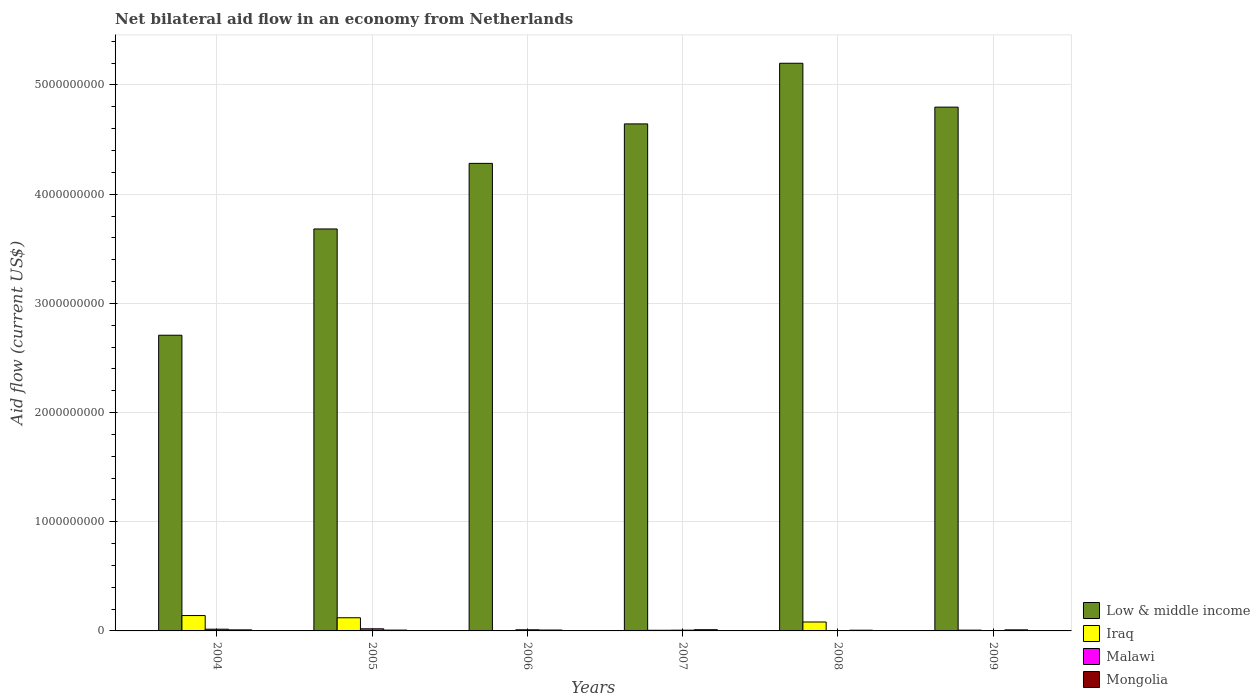How many different coloured bars are there?
Your answer should be compact. 4. How many bars are there on the 4th tick from the right?
Offer a very short reply. 4. What is the label of the 5th group of bars from the left?
Ensure brevity in your answer.  2008. In how many cases, is the number of bars for a given year not equal to the number of legend labels?
Provide a short and direct response. 0. What is the net bilateral aid flow in Malawi in 2009?
Offer a terse response. 8.60e+05. Across all years, what is the maximum net bilateral aid flow in Iraq?
Give a very brief answer. 1.41e+08. Across all years, what is the minimum net bilateral aid flow in Low & middle income?
Your response must be concise. 2.71e+09. In which year was the net bilateral aid flow in Iraq maximum?
Give a very brief answer. 2004. What is the total net bilateral aid flow in Mongolia in the graph?
Your answer should be compact. 5.23e+07. What is the difference between the net bilateral aid flow in Malawi in 2006 and that in 2008?
Offer a very short reply. 1.03e+07. What is the difference between the net bilateral aid flow in Iraq in 2005 and the net bilateral aid flow in Malawi in 2009?
Offer a very short reply. 1.20e+08. What is the average net bilateral aid flow in Malawi per year?
Your response must be concise. 8.90e+06. In the year 2008, what is the difference between the net bilateral aid flow in Malawi and net bilateral aid flow in Low & middle income?
Provide a short and direct response. -5.20e+09. What is the ratio of the net bilateral aid flow in Iraq in 2005 to that in 2006?
Provide a succinct answer. 37.77. Is the net bilateral aid flow in Iraq in 2004 less than that in 2005?
Your answer should be compact. No. Is the difference between the net bilateral aid flow in Malawi in 2005 and 2007 greater than the difference between the net bilateral aid flow in Low & middle income in 2005 and 2007?
Offer a terse response. Yes. What is the difference between the highest and the second highest net bilateral aid flow in Malawi?
Provide a succinct answer. 3.65e+06. What is the difference between the highest and the lowest net bilateral aid flow in Iraq?
Make the answer very short. 1.38e+08. Is the sum of the net bilateral aid flow in Iraq in 2008 and 2009 greater than the maximum net bilateral aid flow in Malawi across all years?
Provide a succinct answer. Yes. Is it the case that in every year, the sum of the net bilateral aid flow in Mongolia and net bilateral aid flow in Low & middle income is greater than the sum of net bilateral aid flow in Iraq and net bilateral aid flow in Malawi?
Provide a short and direct response. No. How many bars are there?
Offer a very short reply. 24. Are all the bars in the graph horizontal?
Your response must be concise. No. How many years are there in the graph?
Your answer should be very brief. 6. What is the difference between two consecutive major ticks on the Y-axis?
Make the answer very short. 1.00e+09. Does the graph contain any zero values?
Provide a short and direct response. No. Where does the legend appear in the graph?
Give a very brief answer. Bottom right. How many legend labels are there?
Give a very brief answer. 4. How are the legend labels stacked?
Provide a succinct answer. Vertical. What is the title of the graph?
Your response must be concise. Net bilateral aid flow in an economy from Netherlands. Does "Georgia" appear as one of the legend labels in the graph?
Offer a terse response. No. What is the label or title of the Y-axis?
Give a very brief answer. Aid flow (current US$). What is the Aid flow (current US$) in Low & middle income in 2004?
Provide a succinct answer. 2.71e+09. What is the Aid flow (current US$) in Iraq in 2004?
Keep it short and to the point. 1.41e+08. What is the Aid flow (current US$) of Malawi in 2004?
Your answer should be compact. 1.58e+07. What is the Aid flow (current US$) in Mongolia in 2004?
Provide a succinct answer. 9.51e+06. What is the Aid flow (current US$) in Low & middle income in 2005?
Ensure brevity in your answer.  3.68e+09. What is the Aid flow (current US$) in Iraq in 2005?
Provide a short and direct response. 1.20e+08. What is the Aid flow (current US$) of Malawi in 2005?
Your answer should be compact. 1.94e+07. What is the Aid flow (current US$) in Mongolia in 2005?
Provide a succinct answer. 7.49e+06. What is the Aid flow (current US$) in Low & middle income in 2006?
Make the answer very short. 4.28e+09. What is the Aid flow (current US$) of Iraq in 2006?
Your answer should be compact. 3.19e+06. What is the Aid flow (current US$) of Malawi in 2006?
Keep it short and to the point. 1.04e+07. What is the Aid flow (current US$) in Mongolia in 2006?
Ensure brevity in your answer.  8.02e+06. What is the Aid flow (current US$) of Low & middle income in 2007?
Offer a terse response. 4.64e+09. What is the Aid flow (current US$) in Iraq in 2007?
Make the answer very short. 5.94e+06. What is the Aid flow (current US$) in Malawi in 2007?
Your answer should be compact. 6.80e+06. What is the Aid flow (current US$) in Mongolia in 2007?
Offer a terse response. 1.11e+07. What is the Aid flow (current US$) in Low & middle income in 2008?
Keep it short and to the point. 5.20e+09. What is the Aid flow (current US$) in Iraq in 2008?
Your response must be concise. 8.18e+07. What is the Aid flow (current US$) of Malawi in 2008?
Offer a terse response. 1.30e+05. What is the Aid flow (current US$) of Mongolia in 2008?
Ensure brevity in your answer.  6.55e+06. What is the Aid flow (current US$) of Low & middle income in 2009?
Your answer should be compact. 4.80e+09. What is the Aid flow (current US$) in Iraq in 2009?
Provide a succinct answer. 7.27e+06. What is the Aid flow (current US$) of Malawi in 2009?
Give a very brief answer. 8.60e+05. What is the Aid flow (current US$) in Mongolia in 2009?
Ensure brevity in your answer.  9.62e+06. Across all years, what is the maximum Aid flow (current US$) of Low & middle income?
Give a very brief answer. 5.20e+09. Across all years, what is the maximum Aid flow (current US$) of Iraq?
Ensure brevity in your answer.  1.41e+08. Across all years, what is the maximum Aid flow (current US$) in Malawi?
Offer a terse response. 1.94e+07. Across all years, what is the maximum Aid flow (current US$) of Mongolia?
Your answer should be compact. 1.11e+07. Across all years, what is the minimum Aid flow (current US$) in Low & middle income?
Ensure brevity in your answer.  2.71e+09. Across all years, what is the minimum Aid flow (current US$) in Iraq?
Provide a succinct answer. 3.19e+06. Across all years, what is the minimum Aid flow (current US$) in Malawi?
Offer a terse response. 1.30e+05. Across all years, what is the minimum Aid flow (current US$) in Mongolia?
Provide a succinct answer. 6.55e+06. What is the total Aid flow (current US$) of Low & middle income in the graph?
Give a very brief answer. 2.53e+1. What is the total Aid flow (current US$) of Iraq in the graph?
Provide a short and direct response. 3.60e+08. What is the total Aid flow (current US$) in Malawi in the graph?
Give a very brief answer. 5.34e+07. What is the total Aid flow (current US$) of Mongolia in the graph?
Provide a short and direct response. 5.23e+07. What is the difference between the Aid flow (current US$) of Low & middle income in 2004 and that in 2005?
Provide a succinct answer. -9.73e+08. What is the difference between the Aid flow (current US$) of Iraq in 2004 and that in 2005?
Offer a very short reply. 2.03e+07. What is the difference between the Aid flow (current US$) in Malawi in 2004 and that in 2005?
Your response must be concise. -3.65e+06. What is the difference between the Aid flow (current US$) in Mongolia in 2004 and that in 2005?
Ensure brevity in your answer.  2.02e+06. What is the difference between the Aid flow (current US$) of Low & middle income in 2004 and that in 2006?
Provide a succinct answer. -1.57e+09. What is the difference between the Aid flow (current US$) of Iraq in 2004 and that in 2006?
Ensure brevity in your answer.  1.38e+08. What is the difference between the Aid flow (current US$) of Malawi in 2004 and that in 2006?
Your response must be concise. 5.32e+06. What is the difference between the Aid flow (current US$) of Mongolia in 2004 and that in 2006?
Your answer should be compact. 1.49e+06. What is the difference between the Aid flow (current US$) of Low & middle income in 2004 and that in 2007?
Make the answer very short. -1.94e+09. What is the difference between the Aid flow (current US$) in Iraq in 2004 and that in 2007?
Make the answer very short. 1.35e+08. What is the difference between the Aid flow (current US$) of Malawi in 2004 and that in 2007?
Provide a short and direct response. 8.96e+06. What is the difference between the Aid flow (current US$) of Mongolia in 2004 and that in 2007?
Your answer should be very brief. -1.63e+06. What is the difference between the Aid flow (current US$) of Low & middle income in 2004 and that in 2008?
Make the answer very short. -2.49e+09. What is the difference between the Aid flow (current US$) of Iraq in 2004 and that in 2008?
Provide a short and direct response. 5.90e+07. What is the difference between the Aid flow (current US$) of Malawi in 2004 and that in 2008?
Provide a succinct answer. 1.56e+07. What is the difference between the Aid flow (current US$) in Mongolia in 2004 and that in 2008?
Your answer should be compact. 2.96e+06. What is the difference between the Aid flow (current US$) of Low & middle income in 2004 and that in 2009?
Offer a very short reply. -2.09e+09. What is the difference between the Aid flow (current US$) of Iraq in 2004 and that in 2009?
Offer a very short reply. 1.34e+08. What is the difference between the Aid flow (current US$) in Malawi in 2004 and that in 2009?
Keep it short and to the point. 1.49e+07. What is the difference between the Aid flow (current US$) of Low & middle income in 2005 and that in 2006?
Make the answer very short. -6.01e+08. What is the difference between the Aid flow (current US$) in Iraq in 2005 and that in 2006?
Your answer should be compact. 1.17e+08. What is the difference between the Aid flow (current US$) of Malawi in 2005 and that in 2006?
Offer a terse response. 8.97e+06. What is the difference between the Aid flow (current US$) in Mongolia in 2005 and that in 2006?
Your answer should be very brief. -5.30e+05. What is the difference between the Aid flow (current US$) in Low & middle income in 2005 and that in 2007?
Your answer should be compact. -9.62e+08. What is the difference between the Aid flow (current US$) in Iraq in 2005 and that in 2007?
Your response must be concise. 1.15e+08. What is the difference between the Aid flow (current US$) in Malawi in 2005 and that in 2007?
Your answer should be compact. 1.26e+07. What is the difference between the Aid flow (current US$) in Mongolia in 2005 and that in 2007?
Provide a short and direct response. -3.65e+06. What is the difference between the Aid flow (current US$) of Low & middle income in 2005 and that in 2008?
Ensure brevity in your answer.  -1.52e+09. What is the difference between the Aid flow (current US$) of Iraq in 2005 and that in 2008?
Your answer should be compact. 3.87e+07. What is the difference between the Aid flow (current US$) in Malawi in 2005 and that in 2008?
Provide a succinct answer. 1.93e+07. What is the difference between the Aid flow (current US$) of Mongolia in 2005 and that in 2008?
Give a very brief answer. 9.40e+05. What is the difference between the Aid flow (current US$) of Low & middle income in 2005 and that in 2009?
Provide a short and direct response. -1.12e+09. What is the difference between the Aid flow (current US$) of Iraq in 2005 and that in 2009?
Your response must be concise. 1.13e+08. What is the difference between the Aid flow (current US$) in Malawi in 2005 and that in 2009?
Keep it short and to the point. 1.86e+07. What is the difference between the Aid flow (current US$) in Mongolia in 2005 and that in 2009?
Your response must be concise. -2.13e+06. What is the difference between the Aid flow (current US$) of Low & middle income in 2006 and that in 2007?
Keep it short and to the point. -3.62e+08. What is the difference between the Aid flow (current US$) in Iraq in 2006 and that in 2007?
Your answer should be compact. -2.75e+06. What is the difference between the Aid flow (current US$) in Malawi in 2006 and that in 2007?
Your answer should be very brief. 3.64e+06. What is the difference between the Aid flow (current US$) in Mongolia in 2006 and that in 2007?
Keep it short and to the point. -3.12e+06. What is the difference between the Aid flow (current US$) of Low & middle income in 2006 and that in 2008?
Keep it short and to the point. -9.17e+08. What is the difference between the Aid flow (current US$) of Iraq in 2006 and that in 2008?
Provide a short and direct response. -7.86e+07. What is the difference between the Aid flow (current US$) in Malawi in 2006 and that in 2008?
Keep it short and to the point. 1.03e+07. What is the difference between the Aid flow (current US$) of Mongolia in 2006 and that in 2008?
Keep it short and to the point. 1.47e+06. What is the difference between the Aid flow (current US$) in Low & middle income in 2006 and that in 2009?
Make the answer very short. -5.15e+08. What is the difference between the Aid flow (current US$) in Iraq in 2006 and that in 2009?
Give a very brief answer. -4.08e+06. What is the difference between the Aid flow (current US$) of Malawi in 2006 and that in 2009?
Provide a short and direct response. 9.58e+06. What is the difference between the Aid flow (current US$) of Mongolia in 2006 and that in 2009?
Your answer should be compact. -1.60e+06. What is the difference between the Aid flow (current US$) in Low & middle income in 2007 and that in 2008?
Your answer should be very brief. -5.55e+08. What is the difference between the Aid flow (current US$) in Iraq in 2007 and that in 2008?
Offer a terse response. -7.59e+07. What is the difference between the Aid flow (current US$) in Malawi in 2007 and that in 2008?
Keep it short and to the point. 6.67e+06. What is the difference between the Aid flow (current US$) of Mongolia in 2007 and that in 2008?
Your answer should be very brief. 4.59e+06. What is the difference between the Aid flow (current US$) in Low & middle income in 2007 and that in 2009?
Offer a terse response. -1.54e+08. What is the difference between the Aid flow (current US$) of Iraq in 2007 and that in 2009?
Ensure brevity in your answer.  -1.33e+06. What is the difference between the Aid flow (current US$) of Malawi in 2007 and that in 2009?
Provide a short and direct response. 5.94e+06. What is the difference between the Aid flow (current US$) of Mongolia in 2007 and that in 2009?
Give a very brief answer. 1.52e+06. What is the difference between the Aid flow (current US$) of Low & middle income in 2008 and that in 2009?
Give a very brief answer. 4.02e+08. What is the difference between the Aid flow (current US$) in Iraq in 2008 and that in 2009?
Ensure brevity in your answer.  7.45e+07. What is the difference between the Aid flow (current US$) in Malawi in 2008 and that in 2009?
Provide a short and direct response. -7.30e+05. What is the difference between the Aid flow (current US$) in Mongolia in 2008 and that in 2009?
Your response must be concise. -3.07e+06. What is the difference between the Aid flow (current US$) of Low & middle income in 2004 and the Aid flow (current US$) of Iraq in 2005?
Ensure brevity in your answer.  2.59e+09. What is the difference between the Aid flow (current US$) in Low & middle income in 2004 and the Aid flow (current US$) in Malawi in 2005?
Make the answer very short. 2.69e+09. What is the difference between the Aid flow (current US$) of Low & middle income in 2004 and the Aid flow (current US$) of Mongolia in 2005?
Keep it short and to the point. 2.70e+09. What is the difference between the Aid flow (current US$) of Iraq in 2004 and the Aid flow (current US$) of Malawi in 2005?
Give a very brief answer. 1.21e+08. What is the difference between the Aid flow (current US$) in Iraq in 2004 and the Aid flow (current US$) in Mongolia in 2005?
Provide a succinct answer. 1.33e+08. What is the difference between the Aid flow (current US$) of Malawi in 2004 and the Aid flow (current US$) of Mongolia in 2005?
Ensure brevity in your answer.  8.27e+06. What is the difference between the Aid flow (current US$) of Low & middle income in 2004 and the Aid flow (current US$) of Iraq in 2006?
Make the answer very short. 2.71e+09. What is the difference between the Aid flow (current US$) in Low & middle income in 2004 and the Aid flow (current US$) in Malawi in 2006?
Offer a very short reply. 2.70e+09. What is the difference between the Aid flow (current US$) in Low & middle income in 2004 and the Aid flow (current US$) in Mongolia in 2006?
Keep it short and to the point. 2.70e+09. What is the difference between the Aid flow (current US$) in Iraq in 2004 and the Aid flow (current US$) in Malawi in 2006?
Your answer should be very brief. 1.30e+08. What is the difference between the Aid flow (current US$) in Iraq in 2004 and the Aid flow (current US$) in Mongolia in 2006?
Provide a succinct answer. 1.33e+08. What is the difference between the Aid flow (current US$) of Malawi in 2004 and the Aid flow (current US$) of Mongolia in 2006?
Make the answer very short. 7.74e+06. What is the difference between the Aid flow (current US$) of Low & middle income in 2004 and the Aid flow (current US$) of Iraq in 2007?
Keep it short and to the point. 2.70e+09. What is the difference between the Aid flow (current US$) of Low & middle income in 2004 and the Aid flow (current US$) of Malawi in 2007?
Offer a terse response. 2.70e+09. What is the difference between the Aid flow (current US$) in Low & middle income in 2004 and the Aid flow (current US$) in Mongolia in 2007?
Offer a terse response. 2.70e+09. What is the difference between the Aid flow (current US$) in Iraq in 2004 and the Aid flow (current US$) in Malawi in 2007?
Ensure brevity in your answer.  1.34e+08. What is the difference between the Aid flow (current US$) of Iraq in 2004 and the Aid flow (current US$) of Mongolia in 2007?
Your response must be concise. 1.30e+08. What is the difference between the Aid flow (current US$) of Malawi in 2004 and the Aid flow (current US$) of Mongolia in 2007?
Your answer should be very brief. 4.62e+06. What is the difference between the Aid flow (current US$) of Low & middle income in 2004 and the Aid flow (current US$) of Iraq in 2008?
Your answer should be compact. 2.63e+09. What is the difference between the Aid flow (current US$) of Low & middle income in 2004 and the Aid flow (current US$) of Malawi in 2008?
Your answer should be very brief. 2.71e+09. What is the difference between the Aid flow (current US$) of Low & middle income in 2004 and the Aid flow (current US$) of Mongolia in 2008?
Provide a short and direct response. 2.70e+09. What is the difference between the Aid flow (current US$) in Iraq in 2004 and the Aid flow (current US$) in Malawi in 2008?
Give a very brief answer. 1.41e+08. What is the difference between the Aid flow (current US$) of Iraq in 2004 and the Aid flow (current US$) of Mongolia in 2008?
Provide a succinct answer. 1.34e+08. What is the difference between the Aid flow (current US$) of Malawi in 2004 and the Aid flow (current US$) of Mongolia in 2008?
Offer a terse response. 9.21e+06. What is the difference between the Aid flow (current US$) in Low & middle income in 2004 and the Aid flow (current US$) in Iraq in 2009?
Offer a very short reply. 2.70e+09. What is the difference between the Aid flow (current US$) in Low & middle income in 2004 and the Aid flow (current US$) in Malawi in 2009?
Keep it short and to the point. 2.71e+09. What is the difference between the Aid flow (current US$) in Low & middle income in 2004 and the Aid flow (current US$) in Mongolia in 2009?
Make the answer very short. 2.70e+09. What is the difference between the Aid flow (current US$) in Iraq in 2004 and the Aid flow (current US$) in Malawi in 2009?
Make the answer very short. 1.40e+08. What is the difference between the Aid flow (current US$) in Iraq in 2004 and the Aid flow (current US$) in Mongolia in 2009?
Your response must be concise. 1.31e+08. What is the difference between the Aid flow (current US$) of Malawi in 2004 and the Aid flow (current US$) of Mongolia in 2009?
Provide a short and direct response. 6.14e+06. What is the difference between the Aid flow (current US$) of Low & middle income in 2005 and the Aid flow (current US$) of Iraq in 2006?
Offer a very short reply. 3.68e+09. What is the difference between the Aid flow (current US$) of Low & middle income in 2005 and the Aid flow (current US$) of Malawi in 2006?
Make the answer very short. 3.67e+09. What is the difference between the Aid flow (current US$) of Low & middle income in 2005 and the Aid flow (current US$) of Mongolia in 2006?
Your response must be concise. 3.67e+09. What is the difference between the Aid flow (current US$) in Iraq in 2005 and the Aid flow (current US$) in Malawi in 2006?
Give a very brief answer. 1.10e+08. What is the difference between the Aid flow (current US$) in Iraq in 2005 and the Aid flow (current US$) in Mongolia in 2006?
Offer a very short reply. 1.12e+08. What is the difference between the Aid flow (current US$) in Malawi in 2005 and the Aid flow (current US$) in Mongolia in 2006?
Keep it short and to the point. 1.14e+07. What is the difference between the Aid flow (current US$) in Low & middle income in 2005 and the Aid flow (current US$) in Iraq in 2007?
Ensure brevity in your answer.  3.68e+09. What is the difference between the Aid flow (current US$) of Low & middle income in 2005 and the Aid flow (current US$) of Malawi in 2007?
Offer a very short reply. 3.67e+09. What is the difference between the Aid flow (current US$) in Low & middle income in 2005 and the Aid flow (current US$) in Mongolia in 2007?
Offer a very short reply. 3.67e+09. What is the difference between the Aid flow (current US$) in Iraq in 2005 and the Aid flow (current US$) in Malawi in 2007?
Your response must be concise. 1.14e+08. What is the difference between the Aid flow (current US$) of Iraq in 2005 and the Aid flow (current US$) of Mongolia in 2007?
Your answer should be very brief. 1.09e+08. What is the difference between the Aid flow (current US$) of Malawi in 2005 and the Aid flow (current US$) of Mongolia in 2007?
Your response must be concise. 8.27e+06. What is the difference between the Aid flow (current US$) of Low & middle income in 2005 and the Aid flow (current US$) of Iraq in 2008?
Make the answer very short. 3.60e+09. What is the difference between the Aid flow (current US$) of Low & middle income in 2005 and the Aid flow (current US$) of Malawi in 2008?
Your response must be concise. 3.68e+09. What is the difference between the Aid flow (current US$) in Low & middle income in 2005 and the Aid flow (current US$) in Mongolia in 2008?
Provide a succinct answer. 3.67e+09. What is the difference between the Aid flow (current US$) in Iraq in 2005 and the Aid flow (current US$) in Malawi in 2008?
Provide a short and direct response. 1.20e+08. What is the difference between the Aid flow (current US$) of Iraq in 2005 and the Aid flow (current US$) of Mongolia in 2008?
Make the answer very short. 1.14e+08. What is the difference between the Aid flow (current US$) of Malawi in 2005 and the Aid flow (current US$) of Mongolia in 2008?
Your answer should be compact. 1.29e+07. What is the difference between the Aid flow (current US$) of Low & middle income in 2005 and the Aid flow (current US$) of Iraq in 2009?
Your answer should be compact. 3.67e+09. What is the difference between the Aid flow (current US$) in Low & middle income in 2005 and the Aid flow (current US$) in Malawi in 2009?
Ensure brevity in your answer.  3.68e+09. What is the difference between the Aid flow (current US$) in Low & middle income in 2005 and the Aid flow (current US$) in Mongolia in 2009?
Provide a short and direct response. 3.67e+09. What is the difference between the Aid flow (current US$) of Iraq in 2005 and the Aid flow (current US$) of Malawi in 2009?
Provide a short and direct response. 1.20e+08. What is the difference between the Aid flow (current US$) of Iraq in 2005 and the Aid flow (current US$) of Mongolia in 2009?
Make the answer very short. 1.11e+08. What is the difference between the Aid flow (current US$) of Malawi in 2005 and the Aid flow (current US$) of Mongolia in 2009?
Make the answer very short. 9.79e+06. What is the difference between the Aid flow (current US$) in Low & middle income in 2006 and the Aid flow (current US$) in Iraq in 2007?
Keep it short and to the point. 4.28e+09. What is the difference between the Aid flow (current US$) in Low & middle income in 2006 and the Aid flow (current US$) in Malawi in 2007?
Give a very brief answer. 4.28e+09. What is the difference between the Aid flow (current US$) of Low & middle income in 2006 and the Aid flow (current US$) of Mongolia in 2007?
Keep it short and to the point. 4.27e+09. What is the difference between the Aid flow (current US$) in Iraq in 2006 and the Aid flow (current US$) in Malawi in 2007?
Your answer should be very brief. -3.61e+06. What is the difference between the Aid flow (current US$) in Iraq in 2006 and the Aid flow (current US$) in Mongolia in 2007?
Provide a succinct answer. -7.95e+06. What is the difference between the Aid flow (current US$) of Malawi in 2006 and the Aid flow (current US$) of Mongolia in 2007?
Offer a terse response. -7.00e+05. What is the difference between the Aid flow (current US$) in Low & middle income in 2006 and the Aid flow (current US$) in Iraq in 2008?
Your response must be concise. 4.20e+09. What is the difference between the Aid flow (current US$) of Low & middle income in 2006 and the Aid flow (current US$) of Malawi in 2008?
Provide a succinct answer. 4.28e+09. What is the difference between the Aid flow (current US$) of Low & middle income in 2006 and the Aid flow (current US$) of Mongolia in 2008?
Give a very brief answer. 4.28e+09. What is the difference between the Aid flow (current US$) in Iraq in 2006 and the Aid flow (current US$) in Malawi in 2008?
Offer a very short reply. 3.06e+06. What is the difference between the Aid flow (current US$) of Iraq in 2006 and the Aid flow (current US$) of Mongolia in 2008?
Your answer should be very brief. -3.36e+06. What is the difference between the Aid flow (current US$) of Malawi in 2006 and the Aid flow (current US$) of Mongolia in 2008?
Provide a short and direct response. 3.89e+06. What is the difference between the Aid flow (current US$) of Low & middle income in 2006 and the Aid flow (current US$) of Iraq in 2009?
Your answer should be compact. 4.27e+09. What is the difference between the Aid flow (current US$) of Low & middle income in 2006 and the Aid flow (current US$) of Malawi in 2009?
Ensure brevity in your answer.  4.28e+09. What is the difference between the Aid flow (current US$) of Low & middle income in 2006 and the Aid flow (current US$) of Mongolia in 2009?
Your answer should be compact. 4.27e+09. What is the difference between the Aid flow (current US$) in Iraq in 2006 and the Aid flow (current US$) in Malawi in 2009?
Keep it short and to the point. 2.33e+06. What is the difference between the Aid flow (current US$) in Iraq in 2006 and the Aid flow (current US$) in Mongolia in 2009?
Keep it short and to the point. -6.43e+06. What is the difference between the Aid flow (current US$) of Malawi in 2006 and the Aid flow (current US$) of Mongolia in 2009?
Offer a very short reply. 8.20e+05. What is the difference between the Aid flow (current US$) of Low & middle income in 2007 and the Aid flow (current US$) of Iraq in 2008?
Your answer should be very brief. 4.56e+09. What is the difference between the Aid flow (current US$) of Low & middle income in 2007 and the Aid flow (current US$) of Malawi in 2008?
Offer a terse response. 4.64e+09. What is the difference between the Aid flow (current US$) in Low & middle income in 2007 and the Aid flow (current US$) in Mongolia in 2008?
Offer a terse response. 4.64e+09. What is the difference between the Aid flow (current US$) in Iraq in 2007 and the Aid flow (current US$) in Malawi in 2008?
Your response must be concise. 5.81e+06. What is the difference between the Aid flow (current US$) in Iraq in 2007 and the Aid flow (current US$) in Mongolia in 2008?
Provide a short and direct response. -6.10e+05. What is the difference between the Aid flow (current US$) in Malawi in 2007 and the Aid flow (current US$) in Mongolia in 2008?
Provide a succinct answer. 2.50e+05. What is the difference between the Aid flow (current US$) of Low & middle income in 2007 and the Aid flow (current US$) of Iraq in 2009?
Offer a terse response. 4.64e+09. What is the difference between the Aid flow (current US$) in Low & middle income in 2007 and the Aid flow (current US$) in Malawi in 2009?
Your answer should be very brief. 4.64e+09. What is the difference between the Aid flow (current US$) in Low & middle income in 2007 and the Aid flow (current US$) in Mongolia in 2009?
Make the answer very short. 4.63e+09. What is the difference between the Aid flow (current US$) in Iraq in 2007 and the Aid flow (current US$) in Malawi in 2009?
Offer a terse response. 5.08e+06. What is the difference between the Aid flow (current US$) in Iraq in 2007 and the Aid flow (current US$) in Mongolia in 2009?
Offer a very short reply. -3.68e+06. What is the difference between the Aid flow (current US$) in Malawi in 2007 and the Aid flow (current US$) in Mongolia in 2009?
Make the answer very short. -2.82e+06. What is the difference between the Aid flow (current US$) of Low & middle income in 2008 and the Aid flow (current US$) of Iraq in 2009?
Make the answer very short. 5.19e+09. What is the difference between the Aid flow (current US$) of Low & middle income in 2008 and the Aid flow (current US$) of Malawi in 2009?
Keep it short and to the point. 5.20e+09. What is the difference between the Aid flow (current US$) in Low & middle income in 2008 and the Aid flow (current US$) in Mongolia in 2009?
Your answer should be very brief. 5.19e+09. What is the difference between the Aid flow (current US$) in Iraq in 2008 and the Aid flow (current US$) in Malawi in 2009?
Your answer should be compact. 8.10e+07. What is the difference between the Aid flow (current US$) of Iraq in 2008 and the Aid flow (current US$) of Mongolia in 2009?
Your answer should be compact. 7.22e+07. What is the difference between the Aid flow (current US$) of Malawi in 2008 and the Aid flow (current US$) of Mongolia in 2009?
Offer a terse response. -9.49e+06. What is the average Aid flow (current US$) of Low & middle income per year?
Make the answer very short. 4.22e+09. What is the average Aid flow (current US$) in Iraq per year?
Provide a succinct answer. 5.99e+07. What is the average Aid flow (current US$) of Malawi per year?
Keep it short and to the point. 8.90e+06. What is the average Aid flow (current US$) of Mongolia per year?
Ensure brevity in your answer.  8.72e+06. In the year 2004, what is the difference between the Aid flow (current US$) of Low & middle income and Aid flow (current US$) of Iraq?
Your answer should be very brief. 2.57e+09. In the year 2004, what is the difference between the Aid flow (current US$) of Low & middle income and Aid flow (current US$) of Malawi?
Offer a terse response. 2.69e+09. In the year 2004, what is the difference between the Aid flow (current US$) of Low & middle income and Aid flow (current US$) of Mongolia?
Provide a succinct answer. 2.70e+09. In the year 2004, what is the difference between the Aid flow (current US$) of Iraq and Aid flow (current US$) of Malawi?
Your answer should be very brief. 1.25e+08. In the year 2004, what is the difference between the Aid flow (current US$) of Iraq and Aid flow (current US$) of Mongolia?
Make the answer very short. 1.31e+08. In the year 2004, what is the difference between the Aid flow (current US$) in Malawi and Aid flow (current US$) in Mongolia?
Offer a very short reply. 6.25e+06. In the year 2005, what is the difference between the Aid flow (current US$) in Low & middle income and Aid flow (current US$) in Iraq?
Ensure brevity in your answer.  3.56e+09. In the year 2005, what is the difference between the Aid flow (current US$) in Low & middle income and Aid flow (current US$) in Malawi?
Your answer should be very brief. 3.66e+09. In the year 2005, what is the difference between the Aid flow (current US$) in Low & middle income and Aid flow (current US$) in Mongolia?
Provide a succinct answer. 3.67e+09. In the year 2005, what is the difference between the Aid flow (current US$) of Iraq and Aid flow (current US$) of Malawi?
Offer a terse response. 1.01e+08. In the year 2005, what is the difference between the Aid flow (current US$) of Iraq and Aid flow (current US$) of Mongolia?
Offer a very short reply. 1.13e+08. In the year 2005, what is the difference between the Aid flow (current US$) of Malawi and Aid flow (current US$) of Mongolia?
Give a very brief answer. 1.19e+07. In the year 2006, what is the difference between the Aid flow (current US$) of Low & middle income and Aid flow (current US$) of Iraq?
Give a very brief answer. 4.28e+09. In the year 2006, what is the difference between the Aid flow (current US$) in Low & middle income and Aid flow (current US$) in Malawi?
Ensure brevity in your answer.  4.27e+09. In the year 2006, what is the difference between the Aid flow (current US$) of Low & middle income and Aid flow (current US$) of Mongolia?
Make the answer very short. 4.27e+09. In the year 2006, what is the difference between the Aid flow (current US$) of Iraq and Aid flow (current US$) of Malawi?
Provide a short and direct response. -7.25e+06. In the year 2006, what is the difference between the Aid flow (current US$) of Iraq and Aid flow (current US$) of Mongolia?
Your answer should be compact. -4.83e+06. In the year 2006, what is the difference between the Aid flow (current US$) of Malawi and Aid flow (current US$) of Mongolia?
Your answer should be compact. 2.42e+06. In the year 2007, what is the difference between the Aid flow (current US$) of Low & middle income and Aid flow (current US$) of Iraq?
Your response must be concise. 4.64e+09. In the year 2007, what is the difference between the Aid flow (current US$) in Low & middle income and Aid flow (current US$) in Malawi?
Your answer should be very brief. 4.64e+09. In the year 2007, what is the difference between the Aid flow (current US$) in Low & middle income and Aid flow (current US$) in Mongolia?
Keep it short and to the point. 4.63e+09. In the year 2007, what is the difference between the Aid flow (current US$) in Iraq and Aid flow (current US$) in Malawi?
Offer a very short reply. -8.60e+05. In the year 2007, what is the difference between the Aid flow (current US$) of Iraq and Aid flow (current US$) of Mongolia?
Offer a very short reply. -5.20e+06. In the year 2007, what is the difference between the Aid flow (current US$) of Malawi and Aid flow (current US$) of Mongolia?
Offer a terse response. -4.34e+06. In the year 2008, what is the difference between the Aid flow (current US$) in Low & middle income and Aid flow (current US$) in Iraq?
Ensure brevity in your answer.  5.12e+09. In the year 2008, what is the difference between the Aid flow (current US$) of Low & middle income and Aid flow (current US$) of Malawi?
Your answer should be very brief. 5.20e+09. In the year 2008, what is the difference between the Aid flow (current US$) of Low & middle income and Aid flow (current US$) of Mongolia?
Your answer should be compact. 5.19e+09. In the year 2008, what is the difference between the Aid flow (current US$) of Iraq and Aid flow (current US$) of Malawi?
Ensure brevity in your answer.  8.17e+07. In the year 2008, what is the difference between the Aid flow (current US$) in Iraq and Aid flow (current US$) in Mongolia?
Your answer should be compact. 7.53e+07. In the year 2008, what is the difference between the Aid flow (current US$) of Malawi and Aid flow (current US$) of Mongolia?
Make the answer very short. -6.42e+06. In the year 2009, what is the difference between the Aid flow (current US$) in Low & middle income and Aid flow (current US$) in Iraq?
Offer a terse response. 4.79e+09. In the year 2009, what is the difference between the Aid flow (current US$) of Low & middle income and Aid flow (current US$) of Malawi?
Your answer should be very brief. 4.80e+09. In the year 2009, what is the difference between the Aid flow (current US$) of Low & middle income and Aid flow (current US$) of Mongolia?
Make the answer very short. 4.79e+09. In the year 2009, what is the difference between the Aid flow (current US$) of Iraq and Aid flow (current US$) of Malawi?
Make the answer very short. 6.41e+06. In the year 2009, what is the difference between the Aid flow (current US$) of Iraq and Aid flow (current US$) of Mongolia?
Your answer should be very brief. -2.35e+06. In the year 2009, what is the difference between the Aid flow (current US$) in Malawi and Aid flow (current US$) in Mongolia?
Make the answer very short. -8.76e+06. What is the ratio of the Aid flow (current US$) in Low & middle income in 2004 to that in 2005?
Make the answer very short. 0.74. What is the ratio of the Aid flow (current US$) of Iraq in 2004 to that in 2005?
Give a very brief answer. 1.17. What is the ratio of the Aid flow (current US$) in Malawi in 2004 to that in 2005?
Provide a short and direct response. 0.81. What is the ratio of the Aid flow (current US$) of Mongolia in 2004 to that in 2005?
Your response must be concise. 1.27. What is the ratio of the Aid flow (current US$) of Low & middle income in 2004 to that in 2006?
Your answer should be compact. 0.63. What is the ratio of the Aid flow (current US$) of Iraq in 2004 to that in 2006?
Offer a very short reply. 44.14. What is the ratio of the Aid flow (current US$) of Malawi in 2004 to that in 2006?
Your answer should be very brief. 1.51. What is the ratio of the Aid flow (current US$) in Mongolia in 2004 to that in 2006?
Make the answer very short. 1.19. What is the ratio of the Aid flow (current US$) of Low & middle income in 2004 to that in 2007?
Make the answer very short. 0.58. What is the ratio of the Aid flow (current US$) of Iraq in 2004 to that in 2007?
Provide a short and direct response. 23.7. What is the ratio of the Aid flow (current US$) in Malawi in 2004 to that in 2007?
Provide a succinct answer. 2.32. What is the ratio of the Aid flow (current US$) of Mongolia in 2004 to that in 2007?
Give a very brief answer. 0.85. What is the ratio of the Aid flow (current US$) of Low & middle income in 2004 to that in 2008?
Offer a very short reply. 0.52. What is the ratio of the Aid flow (current US$) in Iraq in 2004 to that in 2008?
Offer a very short reply. 1.72. What is the ratio of the Aid flow (current US$) in Malawi in 2004 to that in 2008?
Provide a succinct answer. 121.23. What is the ratio of the Aid flow (current US$) of Mongolia in 2004 to that in 2008?
Your answer should be compact. 1.45. What is the ratio of the Aid flow (current US$) in Low & middle income in 2004 to that in 2009?
Provide a succinct answer. 0.56. What is the ratio of the Aid flow (current US$) in Iraq in 2004 to that in 2009?
Your answer should be compact. 19.37. What is the ratio of the Aid flow (current US$) of Malawi in 2004 to that in 2009?
Your answer should be very brief. 18.33. What is the ratio of the Aid flow (current US$) in Low & middle income in 2005 to that in 2006?
Provide a short and direct response. 0.86. What is the ratio of the Aid flow (current US$) of Iraq in 2005 to that in 2006?
Provide a short and direct response. 37.77. What is the ratio of the Aid flow (current US$) of Malawi in 2005 to that in 2006?
Make the answer very short. 1.86. What is the ratio of the Aid flow (current US$) in Mongolia in 2005 to that in 2006?
Offer a terse response. 0.93. What is the ratio of the Aid flow (current US$) in Low & middle income in 2005 to that in 2007?
Make the answer very short. 0.79. What is the ratio of the Aid flow (current US$) of Iraq in 2005 to that in 2007?
Provide a succinct answer. 20.29. What is the ratio of the Aid flow (current US$) in Malawi in 2005 to that in 2007?
Your answer should be very brief. 2.85. What is the ratio of the Aid flow (current US$) in Mongolia in 2005 to that in 2007?
Give a very brief answer. 0.67. What is the ratio of the Aid flow (current US$) of Low & middle income in 2005 to that in 2008?
Make the answer very short. 0.71. What is the ratio of the Aid flow (current US$) of Iraq in 2005 to that in 2008?
Offer a very short reply. 1.47. What is the ratio of the Aid flow (current US$) of Malawi in 2005 to that in 2008?
Keep it short and to the point. 149.31. What is the ratio of the Aid flow (current US$) of Mongolia in 2005 to that in 2008?
Your answer should be very brief. 1.14. What is the ratio of the Aid flow (current US$) of Low & middle income in 2005 to that in 2009?
Provide a succinct answer. 0.77. What is the ratio of the Aid flow (current US$) of Iraq in 2005 to that in 2009?
Provide a succinct answer. 16.57. What is the ratio of the Aid flow (current US$) of Malawi in 2005 to that in 2009?
Give a very brief answer. 22.57. What is the ratio of the Aid flow (current US$) in Mongolia in 2005 to that in 2009?
Keep it short and to the point. 0.78. What is the ratio of the Aid flow (current US$) in Low & middle income in 2006 to that in 2007?
Make the answer very short. 0.92. What is the ratio of the Aid flow (current US$) of Iraq in 2006 to that in 2007?
Your answer should be very brief. 0.54. What is the ratio of the Aid flow (current US$) of Malawi in 2006 to that in 2007?
Provide a short and direct response. 1.54. What is the ratio of the Aid flow (current US$) of Mongolia in 2006 to that in 2007?
Offer a very short reply. 0.72. What is the ratio of the Aid flow (current US$) of Low & middle income in 2006 to that in 2008?
Your answer should be very brief. 0.82. What is the ratio of the Aid flow (current US$) in Iraq in 2006 to that in 2008?
Your response must be concise. 0.04. What is the ratio of the Aid flow (current US$) in Malawi in 2006 to that in 2008?
Make the answer very short. 80.31. What is the ratio of the Aid flow (current US$) in Mongolia in 2006 to that in 2008?
Your response must be concise. 1.22. What is the ratio of the Aid flow (current US$) of Low & middle income in 2006 to that in 2009?
Provide a succinct answer. 0.89. What is the ratio of the Aid flow (current US$) of Iraq in 2006 to that in 2009?
Ensure brevity in your answer.  0.44. What is the ratio of the Aid flow (current US$) in Malawi in 2006 to that in 2009?
Give a very brief answer. 12.14. What is the ratio of the Aid flow (current US$) in Mongolia in 2006 to that in 2009?
Your answer should be compact. 0.83. What is the ratio of the Aid flow (current US$) in Low & middle income in 2007 to that in 2008?
Provide a succinct answer. 0.89. What is the ratio of the Aid flow (current US$) in Iraq in 2007 to that in 2008?
Offer a terse response. 0.07. What is the ratio of the Aid flow (current US$) of Malawi in 2007 to that in 2008?
Make the answer very short. 52.31. What is the ratio of the Aid flow (current US$) of Mongolia in 2007 to that in 2008?
Your answer should be very brief. 1.7. What is the ratio of the Aid flow (current US$) in Iraq in 2007 to that in 2009?
Offer a very short reply. 0.82. What is the ratio of the Aid flow (current US$) of Malawi in 2007 to that in 2009?
Ensure brevity in your answer.  7.91. What is the ratio of the Aid flow (current US$) of Mongolia in 2007 to that in 2009?
Your answer should be compact. 1.16. What is the ratio of the Aid flow (current US$) of Low & middle income in 2008 to that in 2009?
Your answer should be very brief. 1.08. What is the ratio of the Aid flow (current US$) in Iraq in 2008 to that in 2009?
Provide a succinct answer. 11.25. What is the ratio of the Aid flow (current US$) of Malawi in 2008 to that in 2009?
Make the answer very short. 0.15. What is the ratio of the Aid flow (current US$) in Mongolia in 2008 to that in 2009?
Ensure brevity in your answer.  0.68. What is the difference between the highest and the second highest Aid flow (current US$) of Low & middle income?
Your response must be concise. 4.02e+08. What is the difference between the highest and the second highest Aid flow (current US$) of Iraq?
Your response must be concise. 2.03e+07. What is the difference between the highest and the second highest Aid flow (current US$) of Malawi?
Your answer should be very brief. 3.65e+06. What is the difference between the highest and the second highest Aid flow (current US$) of Mongolia?
Provide a succinct answer. 1.52e+06. What is the difference between the highest and the lowest Aid flow (current US$) in Low & middle income?
Offer a very short reply. 2.49e+09. What is the difference between the highest and the lowest Aid flow (current US$) of Iraq?
Provide a short and direct response. 1.38e+08. What is the difference between the highest and the lowest Aid flow (current US$) in Malawi?
Offer a very short reply. 1.93e+07. What is the difference between the highest and the lowest Aid flow (current US$) in Mongolia?
Provide a short and direct response. 4.59e+06. 